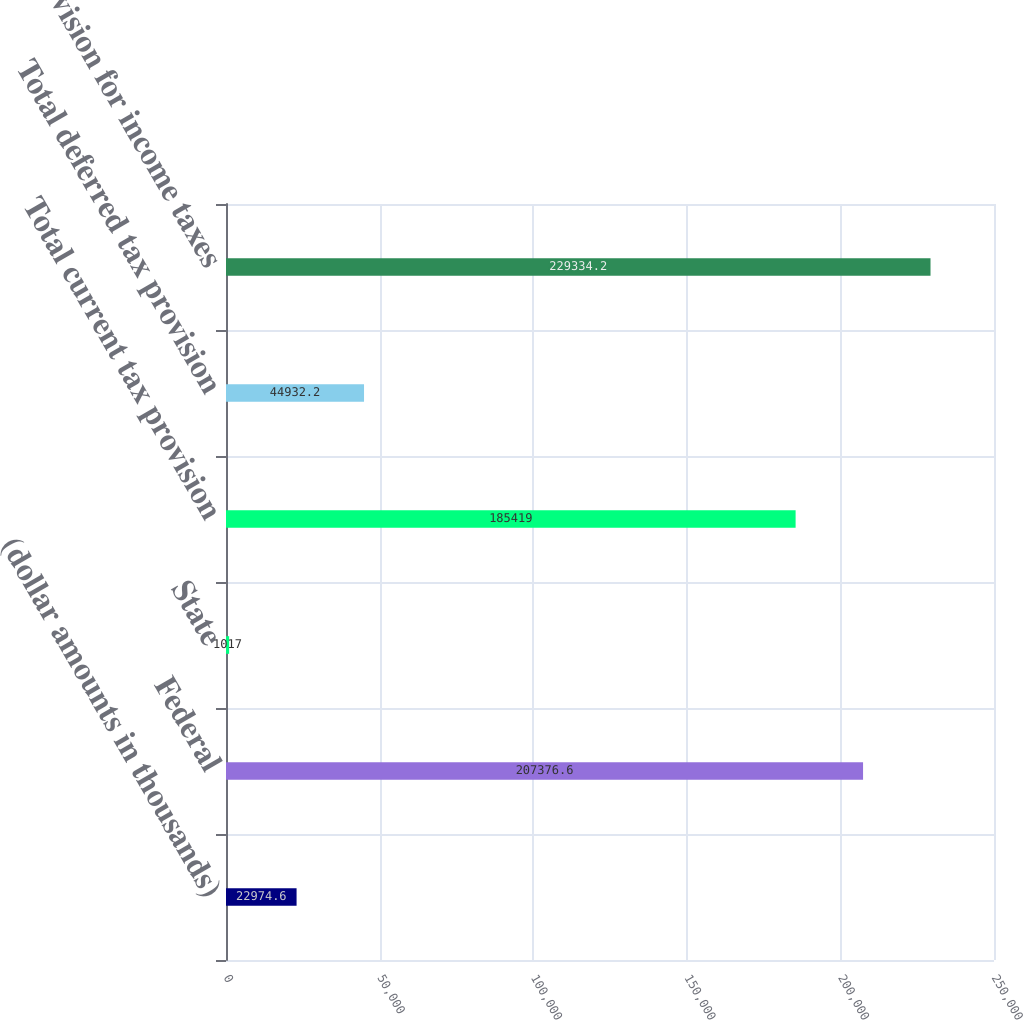Convert chart to OTSL. <chart><loc_0><loc_0><loc_500><loc_500><bar_chart><fcel>(dollar amounts in thousands)<fcel>Federal<fcel>State<fcel>Total current tax provision<fcel>Total deferred tax provision<fcel>Provision for income taxes<nl><fcel>22974.6<fcel>207377<fcel>1017<fcel>185419<fcel>44932.2<fcel>229334<nl></chart> 